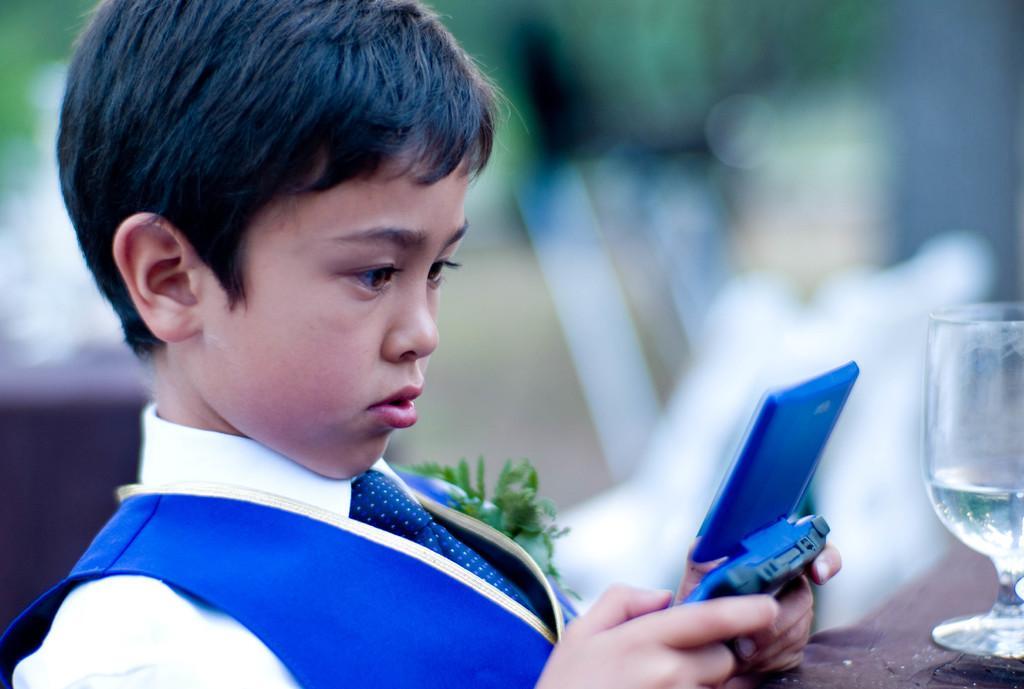Please provide a concise description of this image. In the center of the image there is a boy with a mobile phone. On the right side of the image there is a glass tumbler placed on the table. 